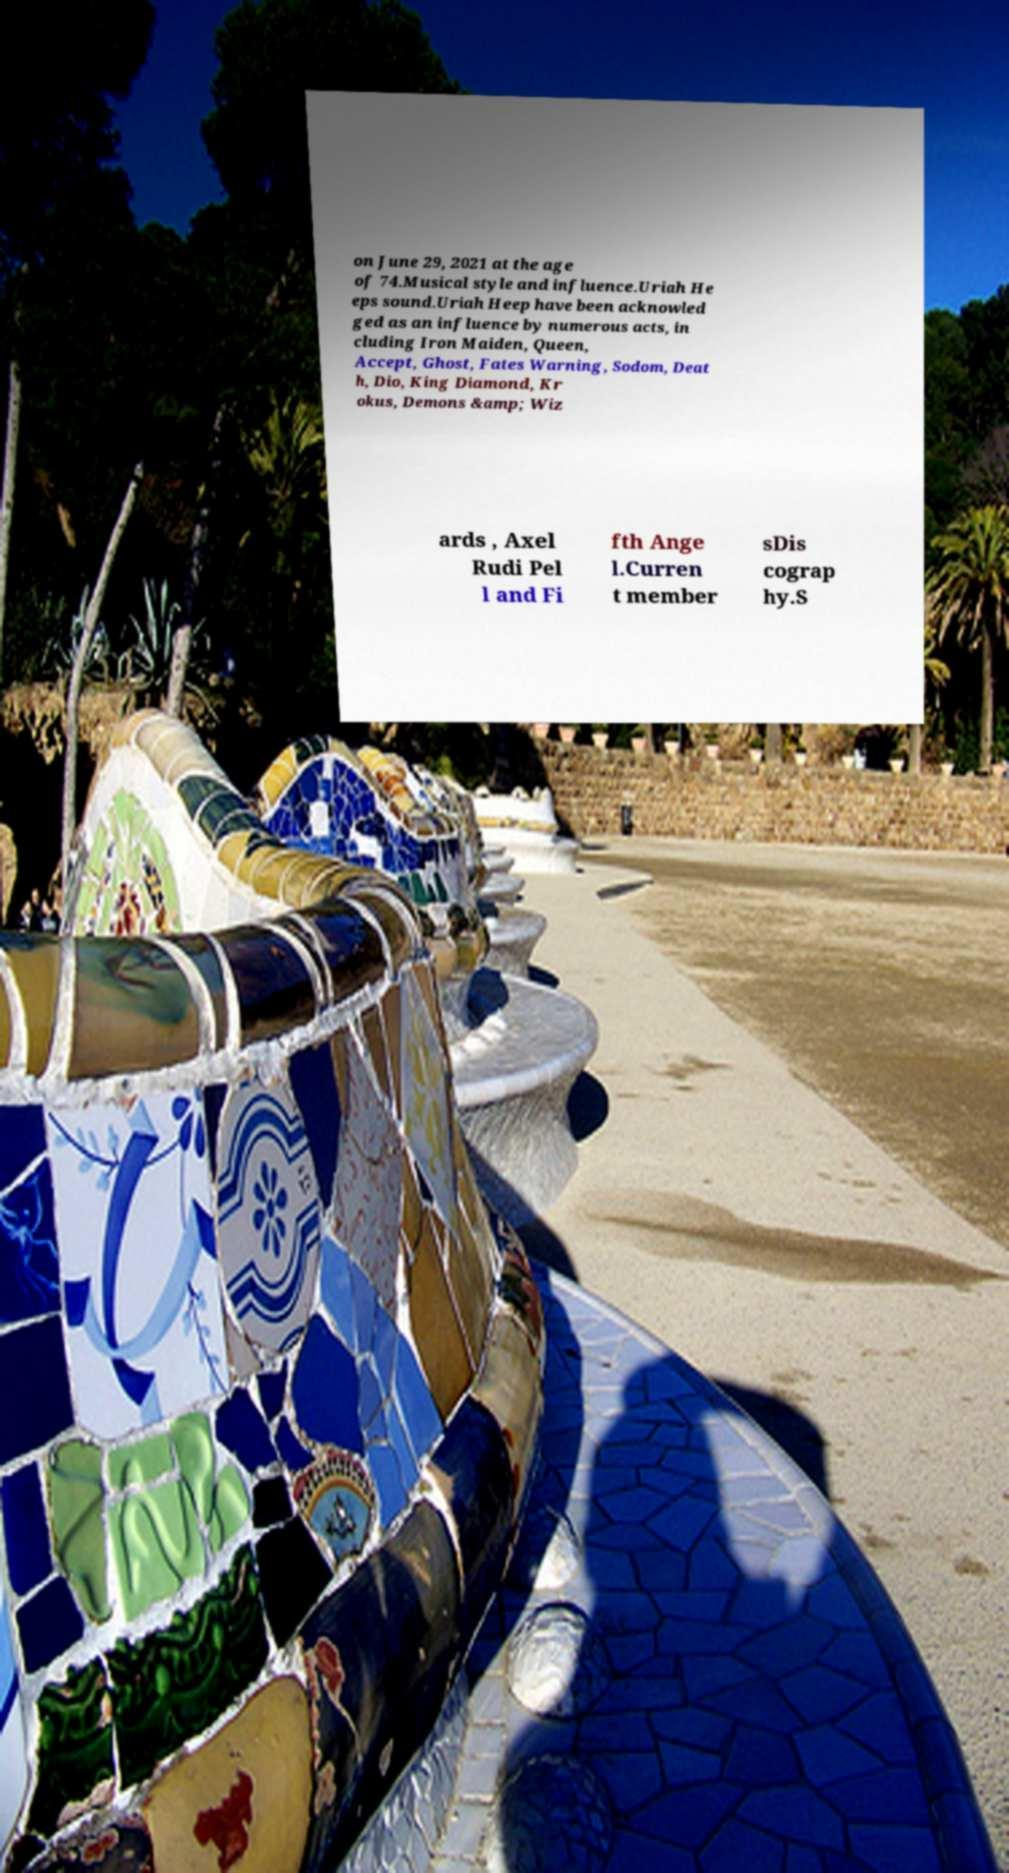Can you read and provide the text displayed in the image?This photo seems to have some interesting text. Can you extract and type it out for me? on June 29, 2021 at the age of 74.Musical style and influence.Uriah He eps sound.Uriah Heep have been acknowled ged as an influence by numerous acts, in cluding Iron Maiden, Queen, Accept, Ghost, Fates Warning, Sodom, Deat h, Dio, King Diamond, Kr okus, Demons &amp; Wiz ards , Axel Rudi Pel l and Fi fth Ange l.Curren t member sDis cograp hy.S 